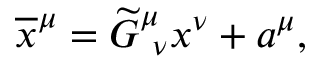<formula> <loc_0><loc_0><loc_500><loc_500>\overline { x } ^ { \mu } = \widetilde { G } _ { \ \nu } ^ { \mu } x ^ { \nu } + a ^ { \mu } ,</formula> 